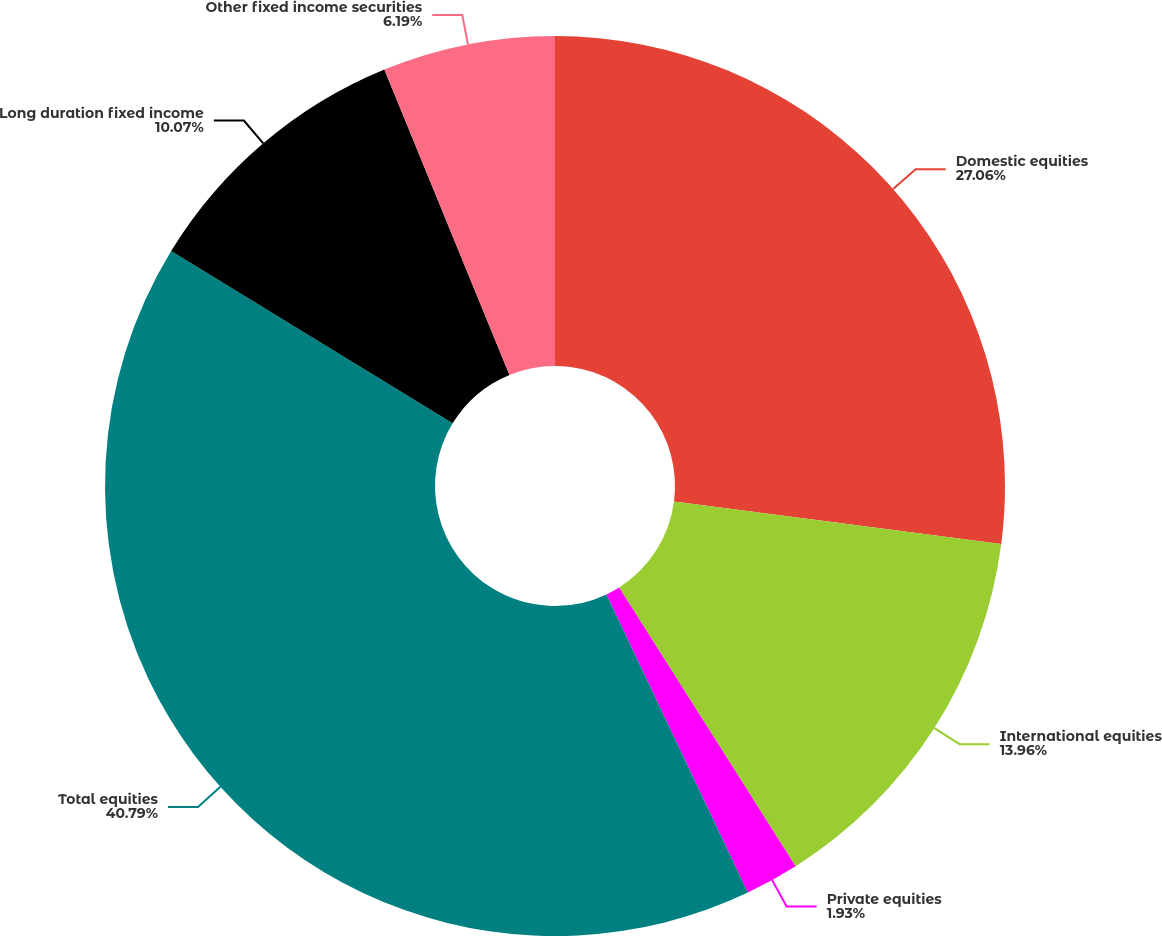<chart> <loc_0><loc_0><loc_500><loc_500><pie_chart><fcel>Domestic equities<fcel>International equities<fcel>Private equities<fcel>Total equities<fcel>Long duration fixed income<fcel>Other fixed income securities<nl><fcel>27.06%<fcel>13.96%<fcel>1.93%<fcel>40.79%<fcel>10.07%<fcel>6.19%<nl></chart> 